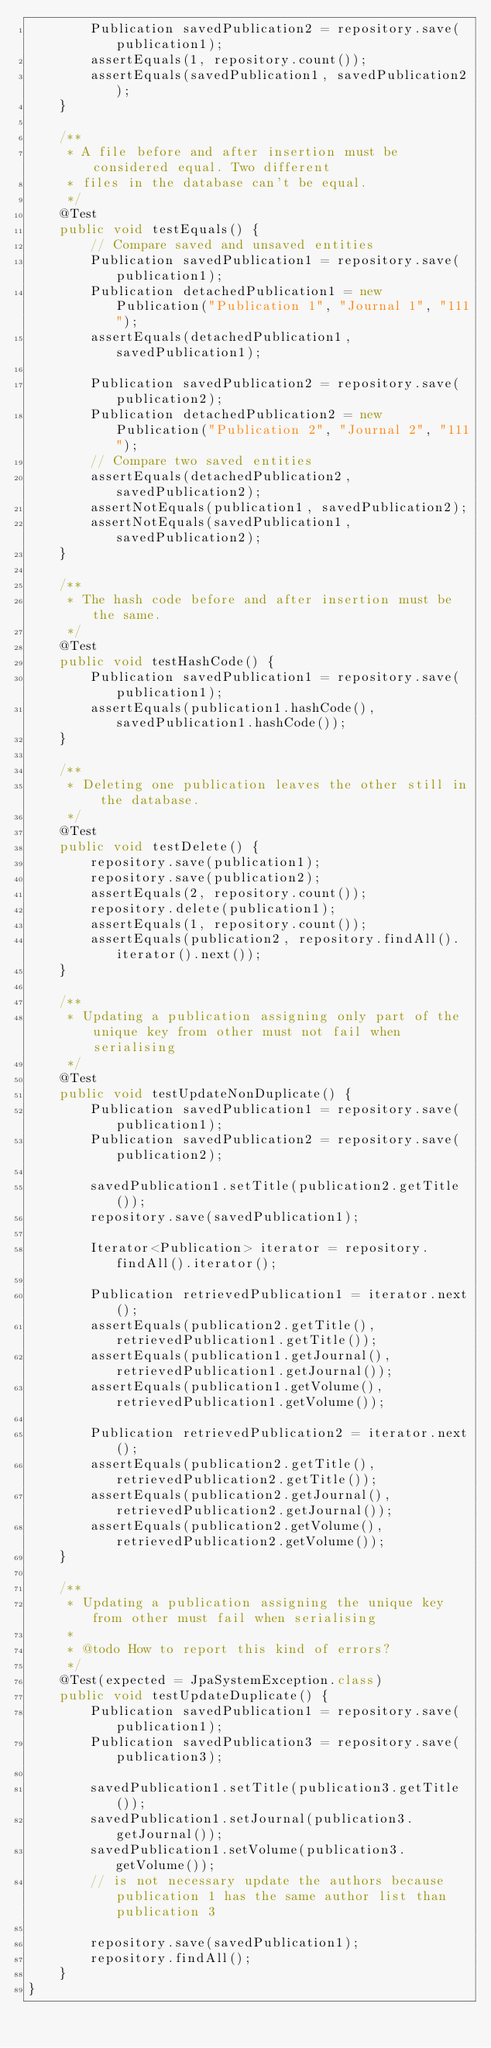<code> <loc_0><loc_0><loc_500><loc_500><_Java_>        Publication savedPublication2 = repository.save(publication1);
        assertEquals(1, repository.count());
        assertEquals(savedPublication1, savedPublication2);
    }

    /**
     * A file before and after insertion must be considered equal. Two different
     * files in the database can't be equal.
     */
    @Test
    public void testEquals() {
        // Compare saved and unsaved entities
        Publication savedPublication1 = repository.save(publication1);
        Publication detachedPublication1 = new Publication("Publication 1", "Journal 1", "111");
        assertEquals(detachedPublication1, savedPublication1);

        Publication savedPublication2 = repository.save(publication2);
        Publication detachedPublication2 = new Publication("Publication 2", "Journal 2", "111");
        // Compare two saved entities
        assertEquals(detachedPublication2, savedPublication2);
        assertNotEquals(publication1, savedPublication2);
        assertNotEquals(savedPublication1, savedPublication2);
    }

    /**
     * The hash code before and after insertion must be the same.
     */
    @Test
    public void testHashCode() {
        Publication savedPublication1 = repository.save(publication1);
        assertEquals(publication1.hashCode(), savedPublication1.hashCode());
    }

    /**
     * Deleting one publication leaves the other still in the database.
     */
    @Test
    public void testDelete() {
        repository.save(publication1);
        repository.save(publication2);
        assertEquals(2, repository.count());
        repository.delete(publication1);
        assertEquals(1, repository.count());
        assertEquals(publication2, repository.findAll().iterator().next());
    }

    /**
     * Updating a publication assigning only part of the unique key from other must not fail when serialising
     */
    @Test
    public void testUpdateNonDuplicate() {
        Publication savedPublication1 = repository.save(publication1);
        Publication savedPublication2 = repository.save(publication2);

        savedPublication1.setTitle(publication2.getTitle());
        repository.save(savedPublication1);

        Iterator<Publication> iterator = repository.findAll().iterator();

        Publication retrievedPublication1 = iterator.next();
        assertEquals(publication2.getTitle(), retrievedPublication1.getTitle());
        assertEquals(publication1.getJournal(), retrievedPublication1.getJournal());
        assertEquals(publication1.getVolume(), retrievedPublication1.getVolume());

        Publication retrievedPublication2 = iterator.next();
        assertEquals(publication2.getTitle(), retrievedPublication2.getTitle());
        assertEquals(publication2.getJournal(), retrievedPublication2.getJournal());
        assertEquals(publication2.getVolume(), retrievedPublication2.getVolume());
    }

    /**
     * Updating a publication assigning the unique key from other must fail when serialising
     *
     * @todo How to report this kind of errors?
     */
    @Test(expected = JpaSystemException.class)
    public void testUpdateDuplicate() {
        Publication savedPublication1 = repository.save(publication1);
        Publication savedPublication3 = repository.save(publication3);

        savedPublication1.setTitle(publication3.getTitle());
        savedPublication1.setJournal(publication3.getJournal());
        savedPublication1.setVolume(publication3.getVolume());
        // is not necessary update the authors because publication 1 has the same author list than publication 3

        repository.save(savedPublication1);
        repository.findAll();
    }
}
</code> 